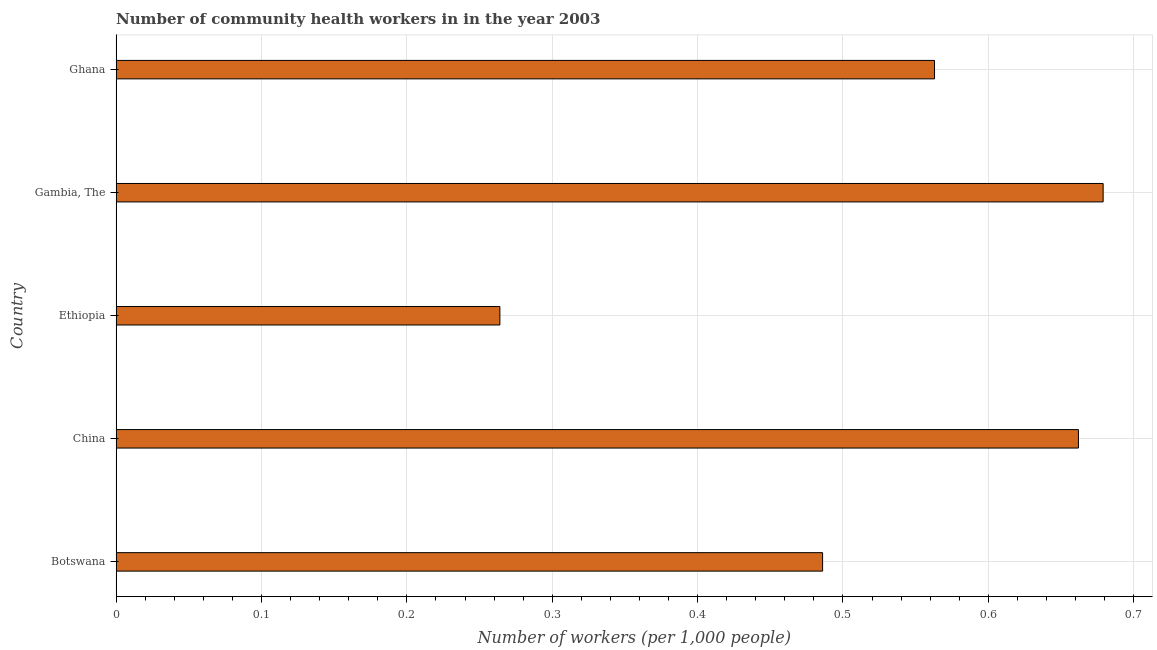Does the graph contain any zero values?
Your answer should be compact. No. Does the graph contain grids?
Give a very brief answer. Yes. What is the title of the graph?
Provide a succinct answer. Number of community health workers in in the year 2003. What is the label or title of the X-axis?
Ensure brevity in your answer.  Number of workers (per 1,0 people). What is the number of community health workers in Gambia, The?
Make the answer very short. 0.68. Across all countries, what is the maximum number of community health workers?
Keep it short and to the point. 0.68. Across all countries, what is the minimum number of community health workers?
Ensure brevity in your answer.  0.26. In which country was the number of community health workers maximum?
Your answer should be very brief. Gambia, The. In which country was the number of community health workers minimum?
Offer a very short reply. Ethiopia. What is the sum of the number of community health workers?
Your answer should be compact. 2.65. What is the difference between the number of community health workers in Botswana and Ghana?
Provide a short and direct response. -0.08. What is the average number of community health workers per country?
Offer a terse response. 0.53. What is the median number of community health workers?
Offer a terse response. 0.56. Is the number of community health workers in Botswana less than that in Ethiopia?
Give a very brief answer. No. Is the difference between the number of community health workers in Ethiopia and Gambia, The greater than the difference between any two countries?
Make the answer very short. Yes. What is the difference between the highest and the second highest number of community health workers?
Provide a succinct answer. 0.02. What is the difference between the highest and the lowest number of community health workers?
Your answer should be compact. 0.42. How many bars are there?
Give a very brief answer. 5. How many countries are there in the graph?
Your answer should be very brief. 5. What is the difference between two consecutive major ticks on the X-axis?
Provide a succinct answer. 0.1. Are the values on the major ticks of X-axis written in scientific E-notation?
Ensure brevity in your answer.  No. What is the Number of workers (per 1,000 people) in Botswana?
Your response must be concise. 0.49. What is the Number of workers (per 1,000 people) of China?
Your response must be concise. 0.66. What is the Number of workers (per 1,000 people) in Ethiopia?
Provide a short and direct response. 0.26. What is the Number of workers (per 1,000 people) of Gambia, The?
Ensure brevity in your answer.  0.68. What is the Number of workers (per 1,000 people) of Ghana?
Provide a succinct answer. 0.56. What is the difference between the Number of workers (per 1,000 people) in Botswana and China?
Provide a succinct answer. -0.18. What is the difference between the Number of workers (per 1,000 people) in Botswana and Ethiopia?
Your response must be concise. 0.22. What is the difference between the Number of workers (per 1,000 people) in Botswana and Gambia, The?
Your answer should be compact. -0.19. What is the difference between the Number of workers (per 1,000 people) in Botswana and Ghana?
Your answer should be compact. -0.08. What is the difference between the Number of workers (per 1,000 people) in China and Ethiopia?
Your answer should be very brief. 0.4. What is the difference between the Number of workers (per 1,000 people) in China and Gambia, The?
Offer a very short reply. -0.02. What is the difference between the Number of workers (per 1,000 people) in China and Ghana?
Your answer should be compact. 0.1. What is the difference between the Number of workers (per 1,000 people) in Ethiopia and Gambia, The?
Ensure brevity in your answer.  -0.41. What is the difference between the Number of workers (per 1,000 people) in Ethiopia and Ghana?
Your answer should be compact. -0.3. What is the difference between the Number of workers (per 1,000 people) in Gambia, The and Ghana?
Ensure brevity in your answer.  0.12. What is the ratio of the Number of workers (per 1,000 people) in Botswana to that in China?
Your response must be concise. 0.73. What is the ratio of the Number of workers (per 1,000 people) in Botswana to that in Ethiopia?
Provide a short and direct response. 1.84. What is the ratio of the Number of workers (per 1,000 people) in Botswana to that in Gambia, The?
Your answer should be compact. 0.72. What is the ratio of the Number of workers (per 1,000 people) in Botswana to that in Ghana?
Offer a very short reply. 0.86. What is the ratio of the Number of workers (per 1,000 people) in China to that in Ethiopia?
Your answer should be very brief. 2.51. What is the ratio of the Number of workers (per 1,000 people) in China to that in Ghana?
Give a very brief answer. 1.18. What is the ratio of the Number of workers (per 1,000 people) in Ethiopia to that in Gambia, The?
Provide a short and direct response. 0.39. What is the ratio of the Number of workers (per 1,000 people) in Ethiopia to that in Ghana?
Ensure brevity in your answer.  0.47. What is the ratio of the Number of workers (per 1,000 people) in Gambia, The to that in Ghana?
Make the answer very short. 1.21. 